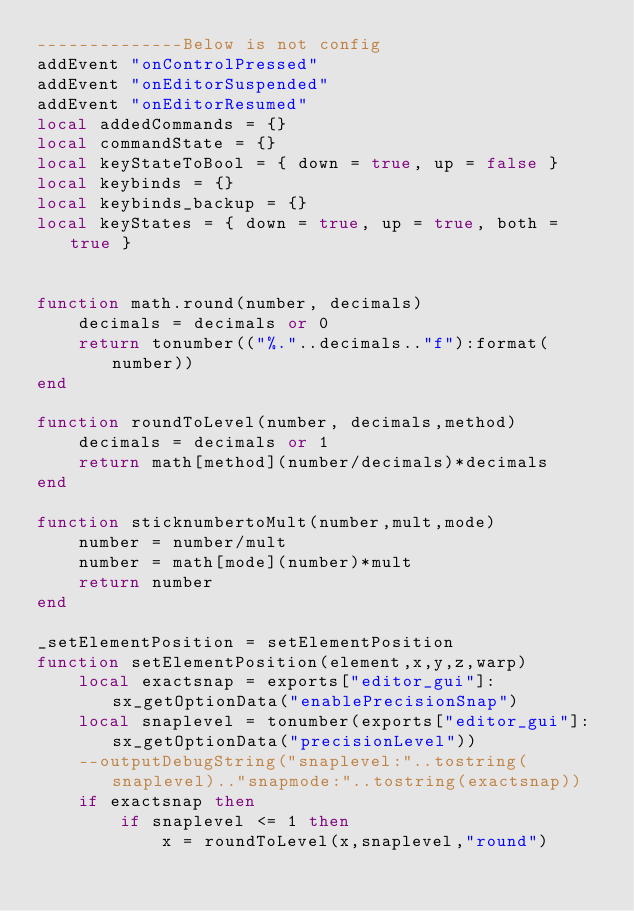Convert code to text. <code><loc_0><loc_0><loc_500><loc_500><_Lua_>--------------Below is not config
addEvent "onControlPressed"
addEvent "onEditorSuspended"
addEvent "onEditorResumed"
local addedCommands = {}
local commandState = {}
local keyStateToBool = { down = true, up = false }
local keybinds = {}
local keybinds_backup = {}
local keyStates = { down = true, up = true, both = true }


function math.round(number, decimals)
    decimals = decimals or 0
    return tonumber(("%."..decimals.."f"):format(number))
end

function roundToLevel(number, decimals,method)
    decimals = decimals or 1
    return math[method](number/decimals)*decimals
end

function sticknumbertoMult(number,mult,mode)
	number = number/mult
	number = math[mode](number)*mult
	return number
end

_setElementPosition = setElementPosition
function setElementPosition(element,x,y,z,warp)
	local exactsnap = exports["editor_gui"]:sx_getOptionData("enablePrecisionSnap")
	local snaplevel = tonumber(exports["editor_gui"]:sx_getOptionData("precisionLevel"))
	--outputDebugString("snaplevel:"..tostring(snaplevel).."snapmode:"..tostring(exactsnap))
	if exactsnap then
		if snaplevel <= 1 then
			x = roundToLevel(x,snaplevel,"round")</code> 